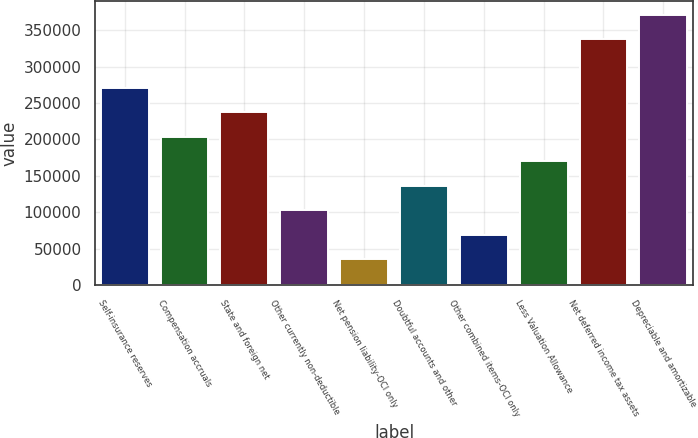Convert chart to OTSL. <chart><loc_0><loc_0><loc_500><loc_500><bar_chart><fcel>Self-insurance reserves<fcel>Compensation accruals<fcel>State and foreign net<fcel>Other currently non-deductible<fcel>Net pension liability-OCI only<fcel>Doubtful accounts and other<fcel>Other combined items-OCI only<fcel>Less Valuation Allowance<fcel>Net deferred income tax assets<fcel>Depreciable and amortizable<nl><fcel>270660<fcel>203651<fcel>237156<fcel>103138<fcel>36128.5<fcel>136642<fcel>69633<fcel>170146<fcel>337669<fcel>371174<nl></chart> 